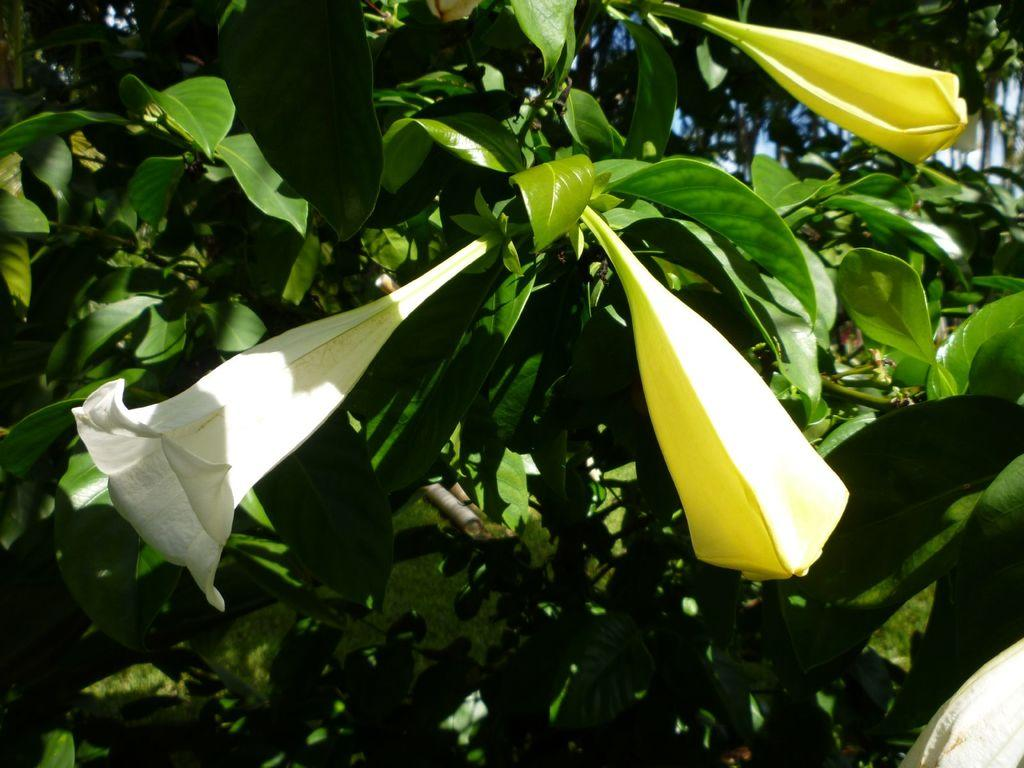What type of plant life can be seen in the image? There are flowers and leaves in the image. Can you describe the flowers in the image? Unfortunately, the facts provided do not give specific details about the flowers. What is the context or setting of the image? The facts provided do not give information about the context or setting of the image. What is the purpose of the drawer in the image? There is no mention of a drawer in the image or the provided facts. 